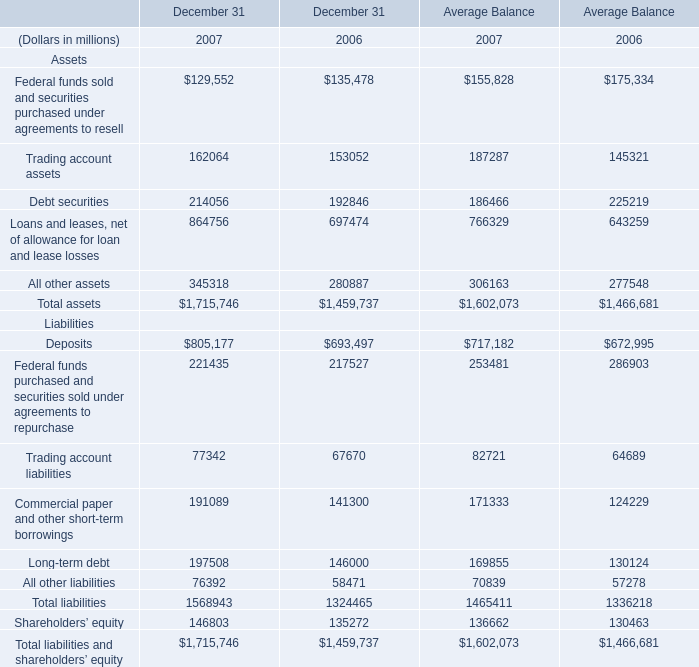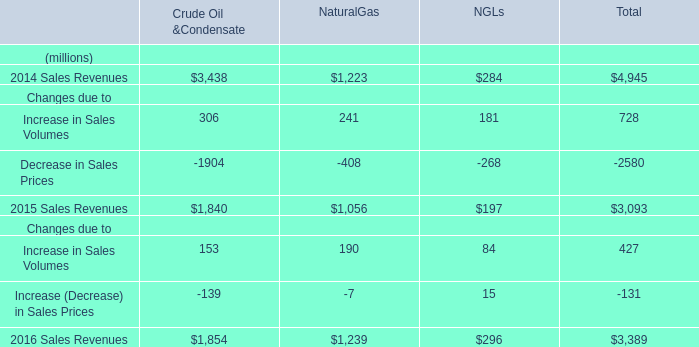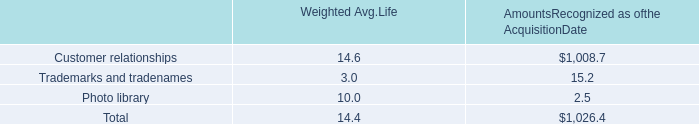What's the current growth rate of Average Balance for Total assets? 
Computations: ((1602073 - 1466681) / 1466681)
Answer: 0.09231. 